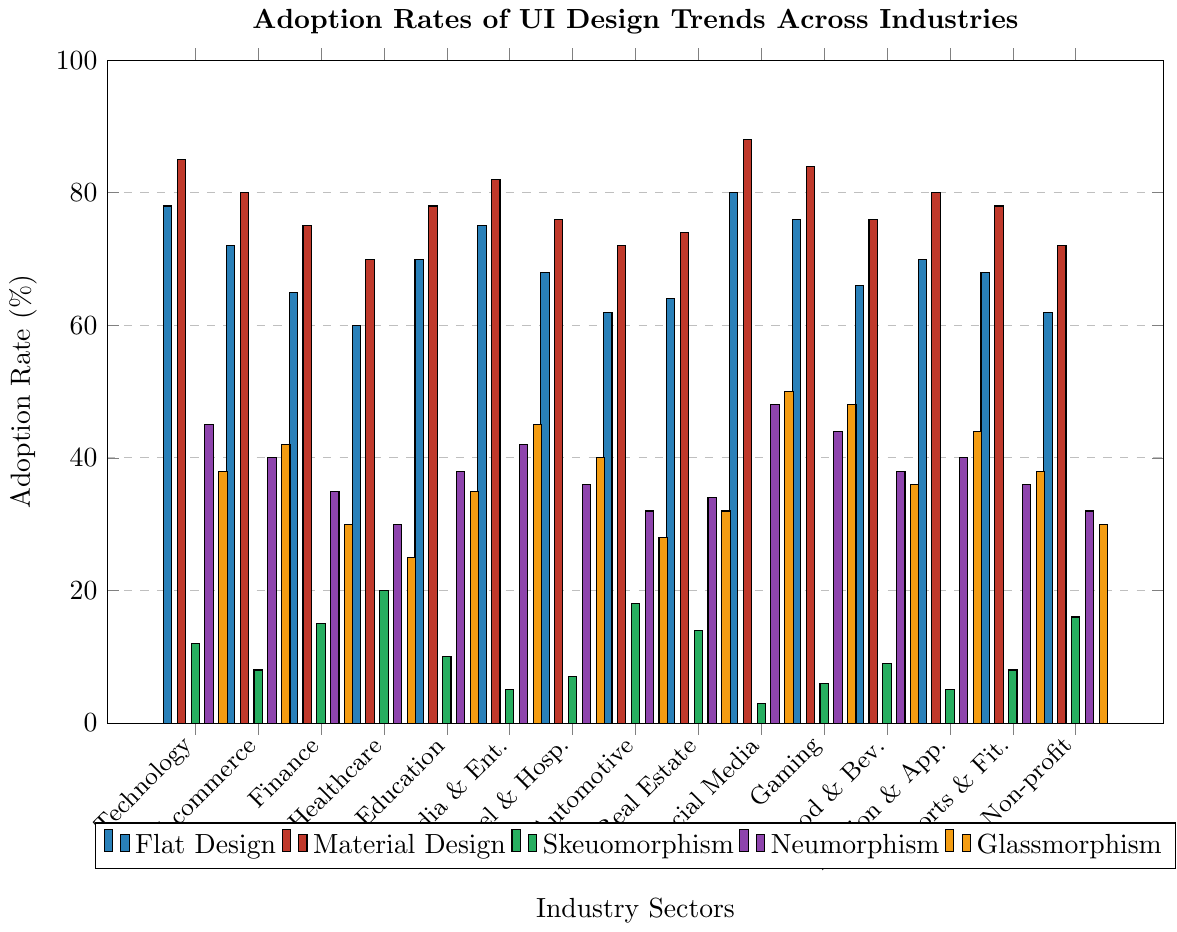Which industry has the highest adoption rate of Material Design? Look at the bars colored red and identify the tallest one. The highest bar is for Social Media, indicating the highest adoption rate.
Answer: Social Media What is the difference in adoption rates of Flat Design and Glassmorphism in the Technology sector? Find the bar heights for Flat Design and Glassmorphism in the Technology sector. Flat Design has a height of 78%, and Glassmorphism has a height of 38%. The difference is 78 - 38 = 40%.
Answer: 40% Which design trend has the lowest adoption rate in the Gaming industry? Observe the bars for the Gaming industry. The lowest bar represents Skeuomorphism with a rate of 6%.
Answer: Skeuomorphism What is the average adoption rate of Neumorphism across all industries? Sum the heights of the bars colored purple across all industries and divide by the number of industries (15). (45 + 40 + 35 + 30 + 38 + 42 + 36 + 32 + 34 + 48 + 44 + 38 + 40 + 36 + 32) / 15 = 35.3%.
Answer: 35.3% How does the adoption rate of Skeuomorphism in the Automotive industry compare to that in the Real Estate industry? Determine the bar heights for Skeuomorphism in Automotive and Real Estate. Automotive has an 18% adoption rate, and Real Estate has a 14% adoption rate. 18 > 14.
Answer: Greater in Automotive Which industry has the highest variance in adoption rates between all design trends? For each industry, subtract the lowest adoption rate from the highest. The largest difference will show the highest variance. Social Media has a variance of 88% (Material Design) - 3% (Skeuomorphism) = 85%.
Answer: Social Media What is the cumulative adoption rate of Flat Design and Material Design in the Finance sector? Add the adoption rates of Flat Design and Material Design for Finance. 65% (Flat Design) + 75% (Material Design) = 140%.
Answer: 140% In which industry is the adoption rate of Neumorphism the highest? Identify the tallest purple bar. The Social Media industry has the highest adoption rate at 48%.
Answer: Social Media Compare the adoption rates of Glassmorphism and Neumorphism in the Healthcare sector and determine the ratio of Glassmorphism to Neumorphism. Find the bar heights for Glassmorphism and Neumorphism in Healthcare. Glassmorphism is 25% and Neumorphism is 30%. The ratio is 25/30 = 5/6 or approximately 0.83.
Answer: 0.83 Which design trend is most uniformly adopted across different industries? Look at the bars for each design trend and observe the variance. Flat Design bars have the least variation in height across industries, indicating uniform adoption.
Answer: Flat Design 